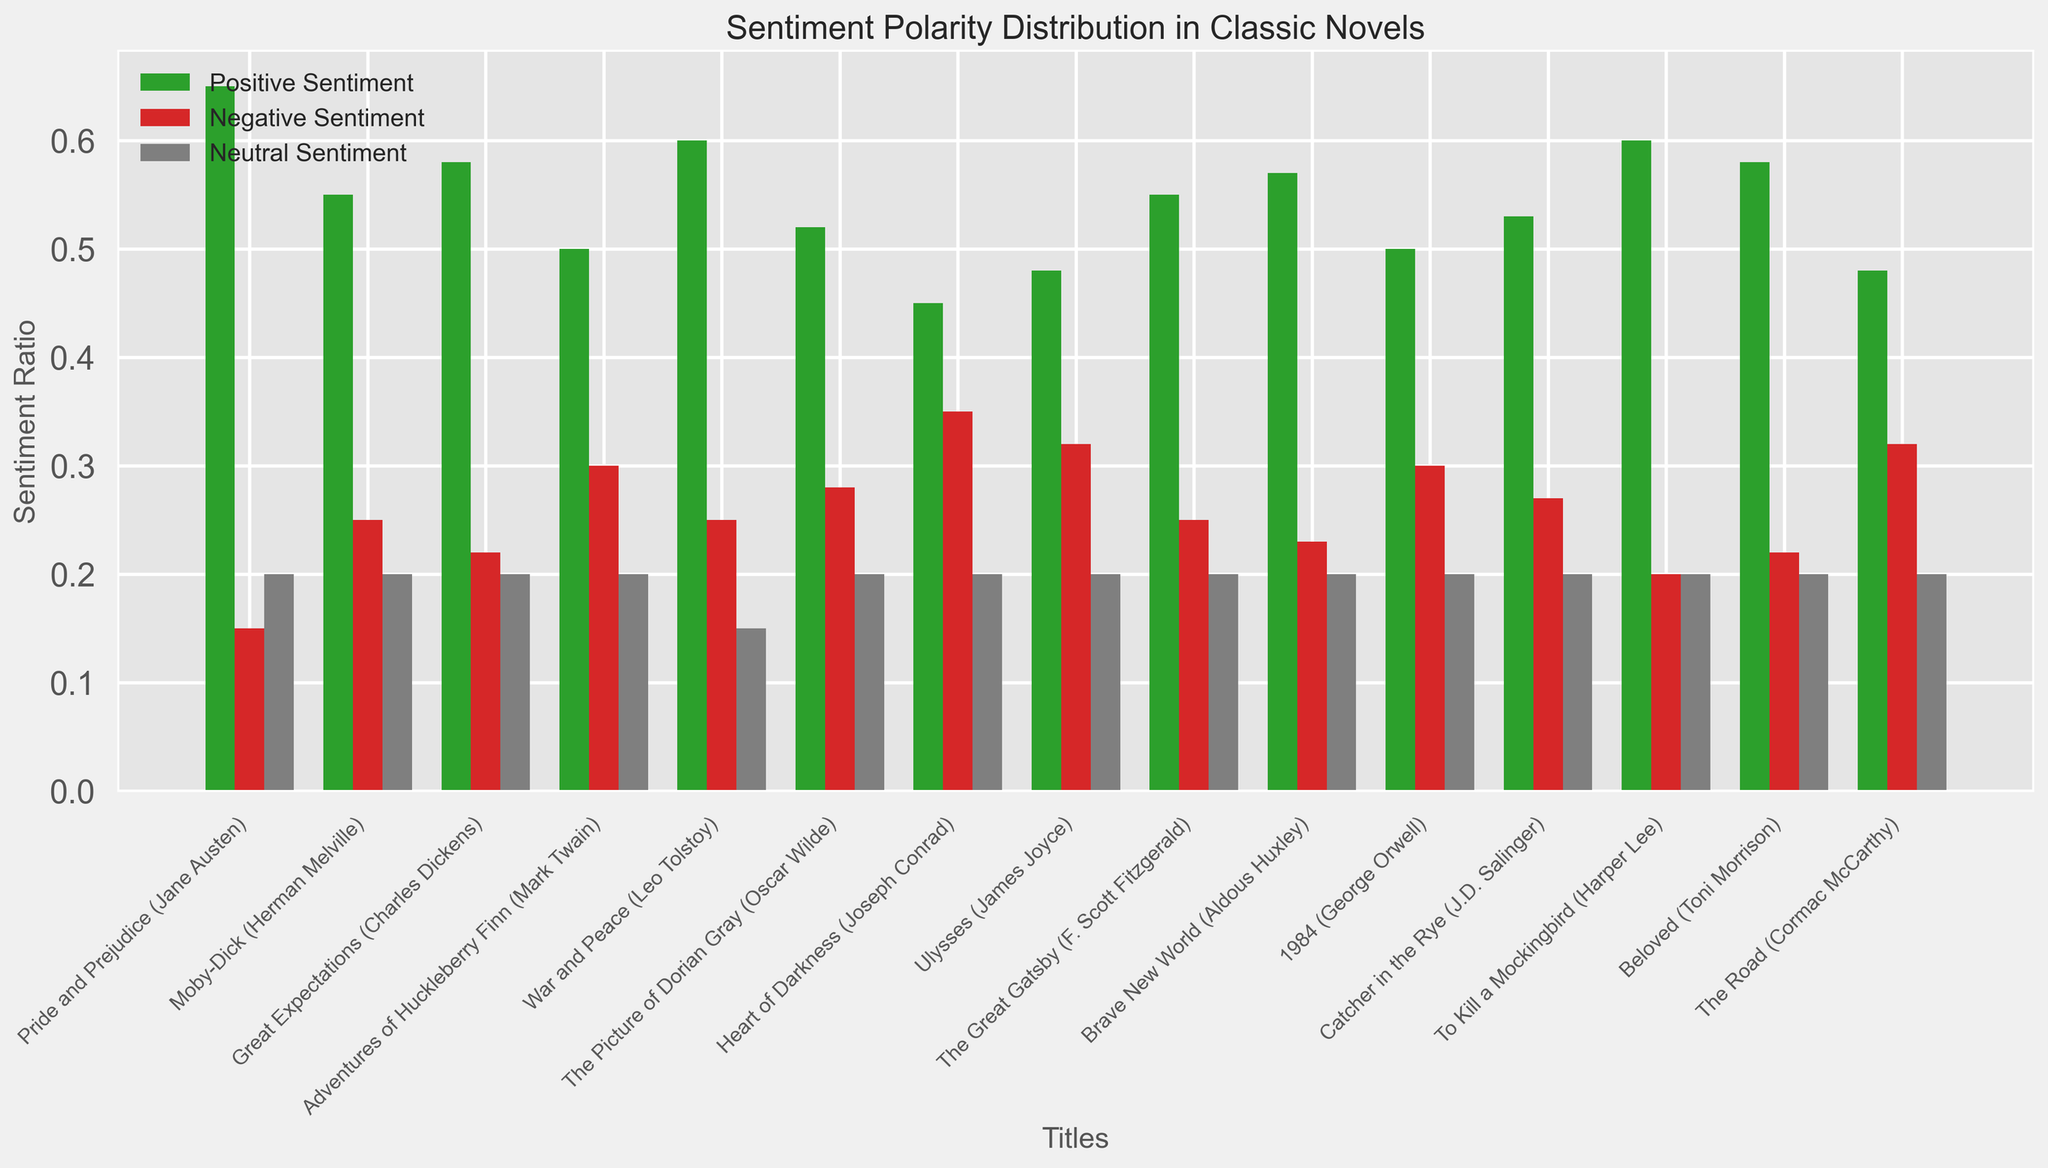Which novel has the highest ratio of positive sentiment? By looking at the green bars representing positive sentiment, identify the novel with the tallest green bar. 'Pride and Prejudice' has the tallest green bar, signifying the highest positive sentiment ratio.
Answer: Pride and Prejudice Which novel in the 1920s has a higher positive sentiment, 'Ulysses' or 'The Great Gatsby'? Compare the heights of the green bars for 'Ulysses' and 'The Great Gatsby'. 'The Great Gatsby' has a taller green bar than 'Ulysses'.
Answer: The Great Gatsby Which novel has the lowest negative sentiment? By observing the red bars representing negative sentiment, identify the novel with the shortest red bar. 'To Kill a Mockingbird' has the shortest red bar.
Answer: To Kill a Mockingbird What is the average negative sentiment ratio for novels in the 1860s? Calculate the average by summing the negative sentiment ratios for 'Great Expectations' (0.22) and 'War and Peace' (0.25) and dividing by 2. (0.22 + 0.25) / 2 = 0.235
Answer: 0.235 What is the difference in positive sentiment between 'Moby-Dick' and 'Heart of Darkness'? Subtract the positive sentiment ratio of 'Heart of Darkness' (0.45) from that of 'Moby-Dick' (0.55). 0.55 - 0.45 = 0.10
Answer: 0.10 How many novels have an equal ratio of neutral sentiment? Count the number of bars for the grey color (neutral sentiment) that have the same height. All novels have a neutral sentiment ratio of 0.20. Since there are 15 novels in total, the answer is 15.
Answer: 15 Which novel has a negative sentiment ratio equal to 'The Great Gatsby'? Compare the heights of red bars to identify the novel with a matching negative sentiment ratio of 0.25. Both 'Moby-Dick' and 'War and Peace' match this ratio.
Answer: Moby-Dick and War and Peace In which time period do novels show the most variation in negative sentiment ratios? Look at the spread or variation in heights of the red bars across different time periods. The 1890s show the most variation with 'The Picture of Dorian Gray' at 0.28 and 'Heart of Darkness' at 0.35.
Answer: 1890s 